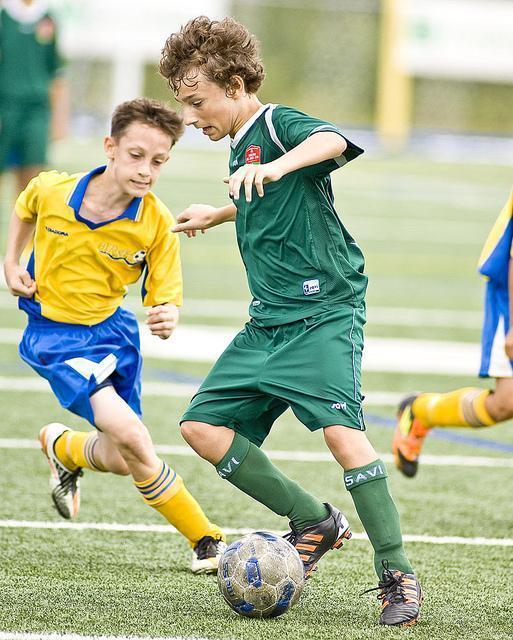How many people are visible?
Give a very brief answer. 4. 